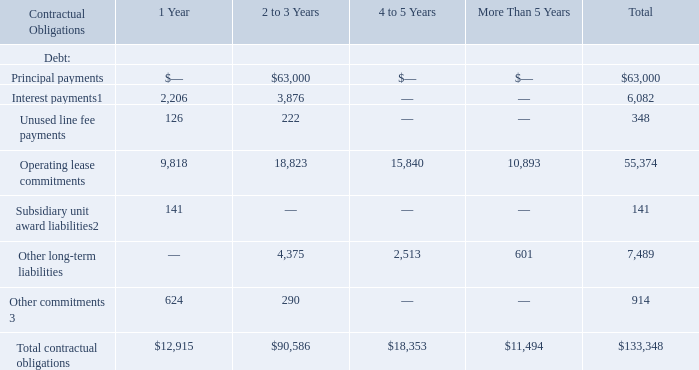Contractual Obligations
Presented below is information about our material contractual obligations and the periods in which those future payments are due as of December 31, 2019. Future events could cause actual payments to differ from these estimates. As of December 31, 2019, the following table summarizes our contractual obligations and the effect such obligations are expected to have on our liquidity and cash flow in future periods (in thousands):
(1) The 2017 Facility incurs interest at a variable rate. The projected variable interest payments assume no change in the Eurodollar Base Rate, or LIBOR, from December 31, 2019.
(2) Represents the current portion of our expected cash payments for our liability to repurchase subsidiary unit awards for our professional residential property management and vacation rental management subsidiary.
(3) Represents amounts due under multi-year, non-cancelable contracts with third-party vendors, as well as other commitments.
The commitment amounts in the table above are associated with contracts that are enforceable and legally binding and that specify all significant terms, including fixed or minimum services to be used, fixed, minimum or variable price provisions, and the approximate timing of the actions under the contracts. The table does not include obligations under agreements that we can cancel without a significant penalty.
As of December 31, 2019, we had no outstanding letters of credit under our 2017 Facility.
What does Subsidiary unit award liabilities represent? The current portion of our expected cash payments for our liability to repurchase subsidiary unit awards for our professional residential property management and vacation rental management subsidiary. What does Other commitments represent? Amounts due under multi-year, non-cancelable contracts with third-party vendors, as well as other commitments. What was the Total contractual obligations across all periods?
Answer scale should be: thousand. $133,348. What was the difference between total other long-term liabilities and total other commitments?
Answer scale should be: thousand. 7,489-914
Answer: 6575. What was the change in total contractual obligations between 1 Year and 2 to 3 Year periods?
Answer scale should be: thousand. 90,586-12,915
Answer: 77671. What was unused line fee payments as a percentage of total contractual obligations across all periods?
Answer scale should be: percent. 348/133,348
Answer: 0.26. 